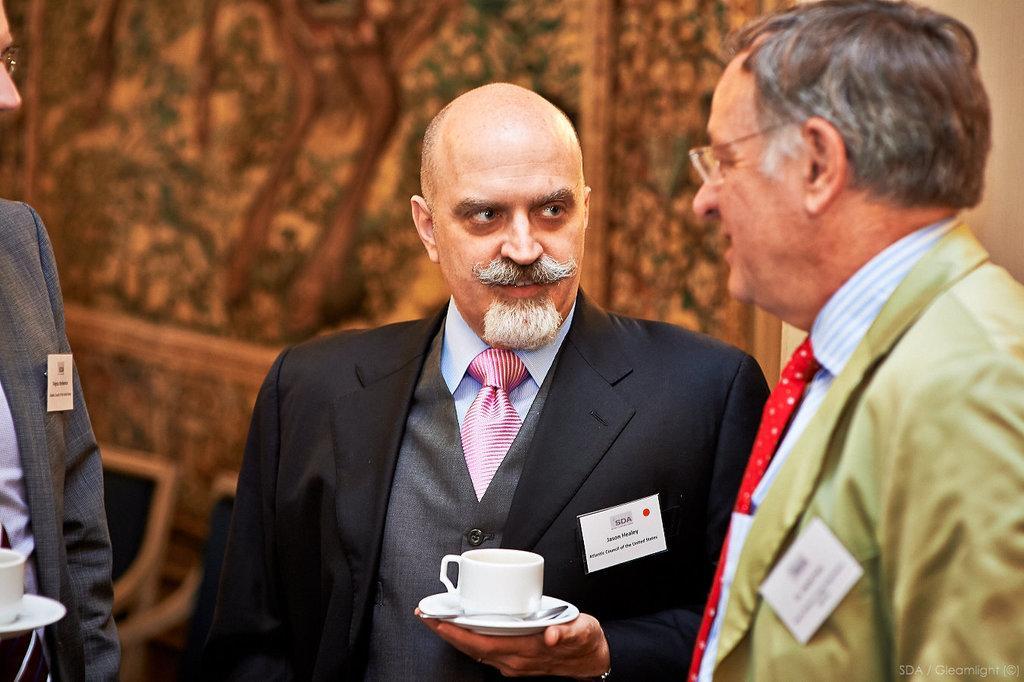In one or two sentences, can you explain what this image depicts? In this image we can see three persons wearing coat are standing. One person is wearing spectacles. One person is holding a cup and spoon in a saucer in his hand. In the background, we can see two chairs. 